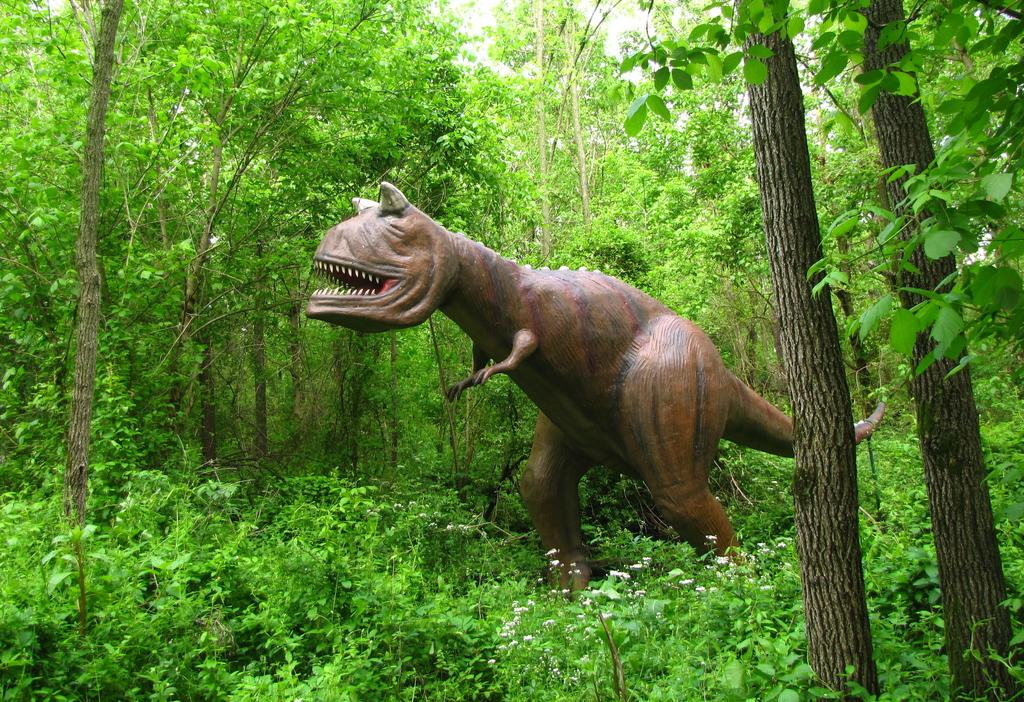What is the main subject of the image? There is a statue of a dinosaur in the image. What type of vegetation can be seen in the image? There are trees with branches and leaves in the image, as well as plants. How many glasses of juice are visible in the image? There is no juice or glasses present in the image. 